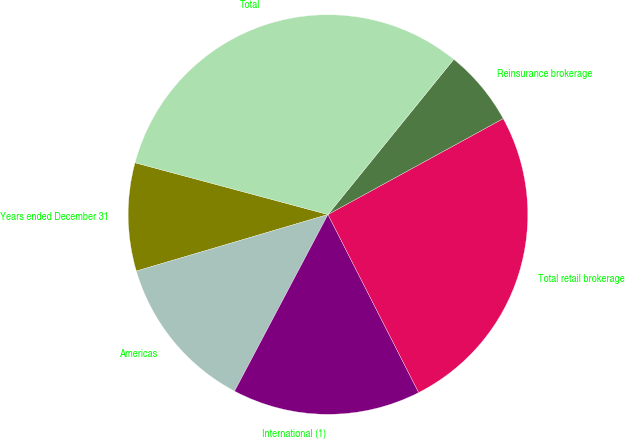Convert chart. <chart><loc_0><loc_0><loc_500><loc_500><pie_chart><fcel>Years ended December 31<fcel>Americas<fcel>International (1)<fcel>Total retail brokerage<fcel>Reinsurance brokerage<fcel>Total<nl><fcel>8.74%<fcel>12.69%<fcel>15.24%<fcel>25.47%<fcel>6.19%<fcel>31.66%<nl></chart> 